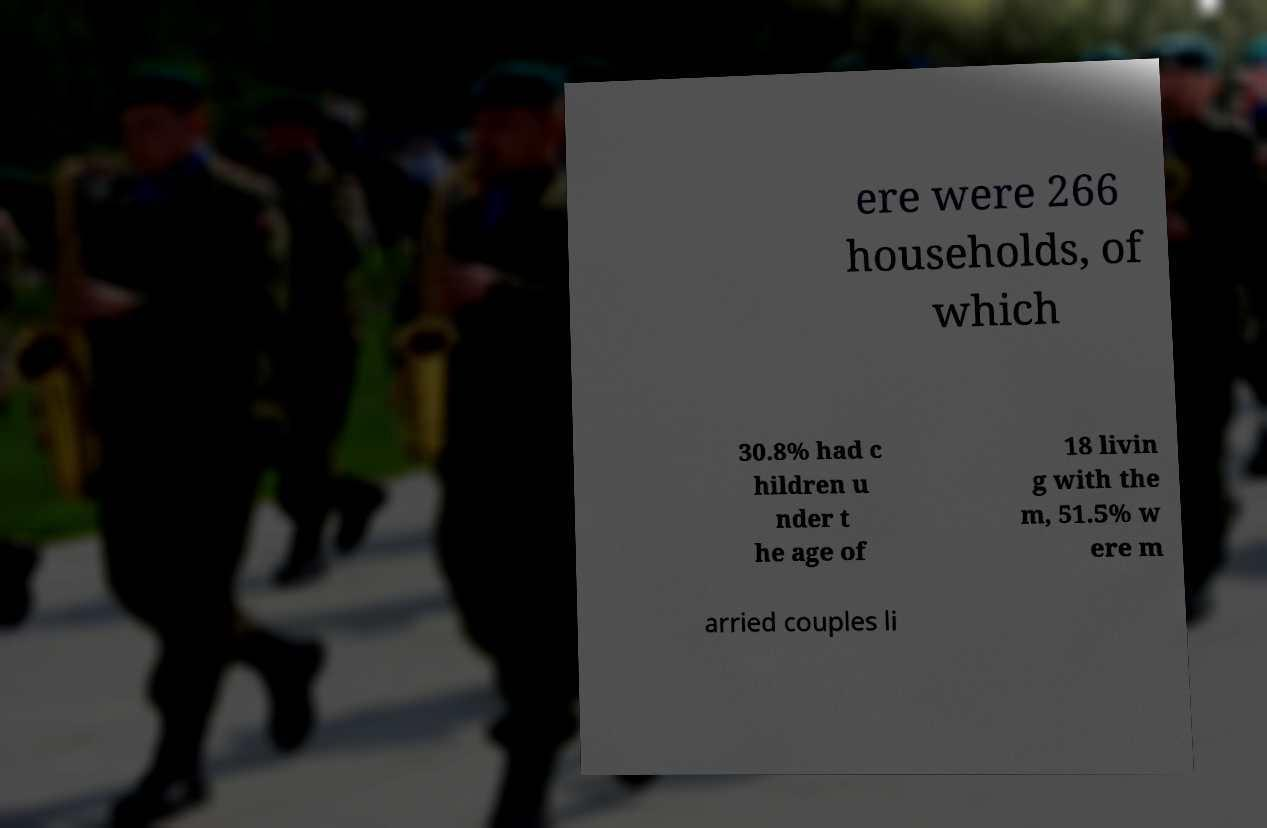Please read and relay the text visible in this image. What does it say? ere were 266 households, of which 30.8% had c hildren u nder t he age of 18 livin g with the m, 51.5% w ere m arried couples li 